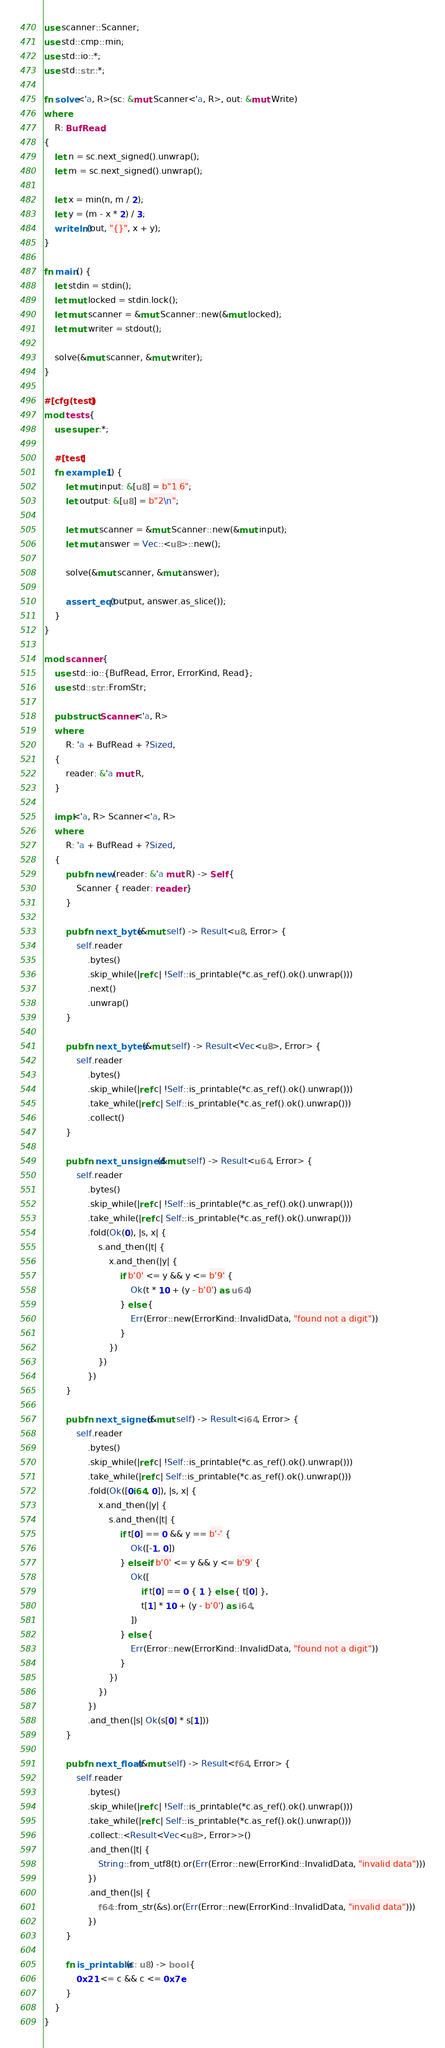<code> <loc_0><loc_0><loc_500><loc_500><_Rust_>use scanner::Scanner;
use std::cmp::min;
use std::io::*;
use std::str::*;

fn solve<'a, R>(sc: &mut Scanner<'a, R>, out: &mut Write)
where
    R: BufRead,
{
    let n = sc.next_signed().unwrap();
    let m = sc.next_signed().unwrap();

    let x = min(n, m / 2);
    let y = (m - x * 2) / 3;
    writeln!(out, "{}", x + y);
}

fn main() {
    let stdin = stdin();
    let mut locked = stdin.lock();
    let mut scanner = &mut Scanner::new(&mut locked);
    let mut writer = stdout();

    solve(&mut scanner, &mut writer);
}

#[cfg(test)]
mod tests {
    use super::*;

    #[test]
    fn example1() {
        let mut input: &[u8] = b"1 6";
        let output: &[u8] = b"2\n";

        let mut scanner = &mut Scanner::new(&mut input);
        let mut answer = Vec::<u8>::new();

        solve(&mut scanner, &mut answer);

        assert_eq!(output, answer.as_slice());
    }
}

mod scanner {
    use std::io::{BufRead, Error, ErrorKind, Read};
    use std::str::FromStr;

    pub struct Scanner<'a, R>
    where
        R: 'a + BufRead + ?Sized,
    {
        reader: &'a mut R,
    }

    impl<'a, R> Scanner<'a, R>
    where
        R: 'a + BufRead + ?Sized,
    {
        pub fn new(reader: &'a mut R) -> Self {
            Scanner { reader: reader }
        }

        pub fn next_byte(&mut self) -> Result<u8, Error> {
            self.reader
                .bytes()
                .skip_while(|ref c| !Self::is_printable(*c.as_ref().ok().unwrap()))
                .next()
                .unwrap()
        }

        pub fn next_bytes(&mut self) -> Result<Vec<u8>, Error> {
            self.reader
                .bytes()
                .skip_while(|ref c| !Self::is_printable(*c.as_ref().ok().unwrap()))
                .take_while(|ref c| Self::is_printable(*c.as_ref().ok().unwrap()))
                .collect()
        }

        pub fn next_unsigned(&mut self) -> Result<u64, Error> {
            self.reader
                .bytes()
                .skip_while(|ref c| !Self::is_printable(*c.as_ref().ok().unwrap()))
                .take_while(|ref c| Self::is_printable(*c.as_ref().ok().unwrap()))
                .fold(Ok(0), |s, x| {
                    s.and_then(|t| {
                        x.and_then(|y| {
                            if b'0' <= y && y <= b'9' {
                                Ok(t * 10 + (y - b'0') as u64)
                            } else {
                                Err(Error::new(ErrorKind::InvalidData, "found not a digit"))
                            }
                        })
                    })
                })
        }

        pub fn next_signed(&mut self) -> Result<i64, Error> {
            self.reader
                .bytes()
                .skip_while(|ref c| !Self::is_printable(*c.as_ref().ok().unwrap()))
                .take_while(|ref c| Self::is_printable(*c.as_ref().ok().unwrap()))
                .fold(Ok([0i64, 0]), |s, x| {
                    x.and_then(|y| {
                        s.and_then(|t| {
                            if t[0] == 0 && y == b'-' {
                                Ok([-1, 0])
                            } else if b'0' <= y && y <= b'9' {
                                Ok([
                                    if t[0] == 0 { 1 } else { t[0] },
                                    t[1] * 10 + (y - b'0') as i64,
                                ])
                            } else {
                                Err(Error::new(ErrorKind::InvalidData, "found not a digit"))
                            }
                        })
                    })
                })
                .and_then(|s| Ok(s[0] * s[1]))
        }

        pub fn next_float(&mut self) -> Result<f64, Error> {
            self.reader
                .bytes()
                .skip_while(|ref c| !Self::is_printable(*c.as_ref().ok().unwrap()))
                .take_while(|ref c| Self::is_printable(*c.as_ref().ok().unwrap()))
                .collect::<Result<Vec<u8>, Error>>()
                .and_then(|t| {
                    String::from_utf8(t).or(Err(Error::new(ErrorKind::InvalidData, "invalid data")))
                })
                .and_then(|s| {
                    f64::from_str(&s).or(Err(Error::new(ErrorKind::InvalidData, "invalid data")))
                })
        }

        fn is_printable(c: u8) -> bool {
            0x21 <= c && c <= 0x7e
        }
    }
}
</code> 